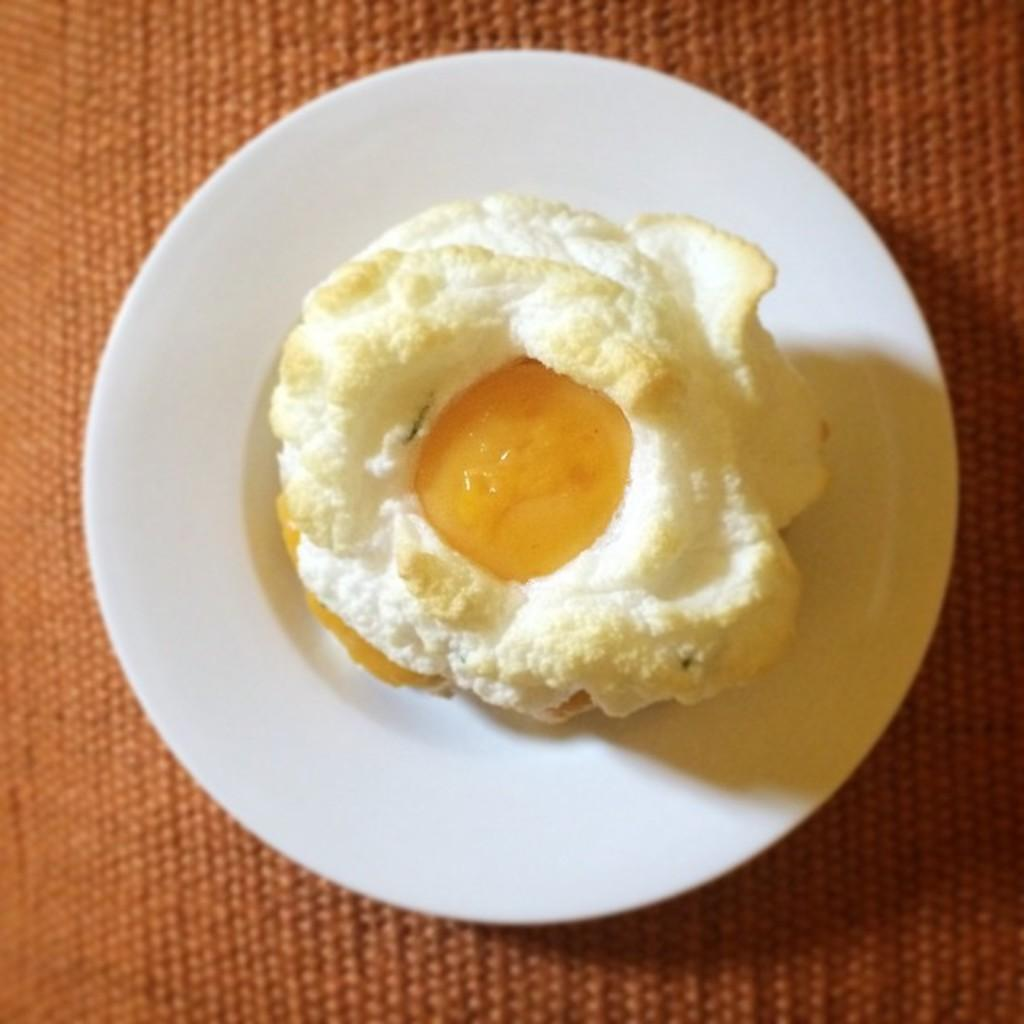What is the main subject in the center of the image? There is an egg poach in the center of the image. What is the egg poach placed on? The egg poach is placed on a plate. Where is the plate located? The plate is placed on a table. What is the opinion of the brush in the image? There is no brush present in the image, so it is not possible to determine its opinion. 